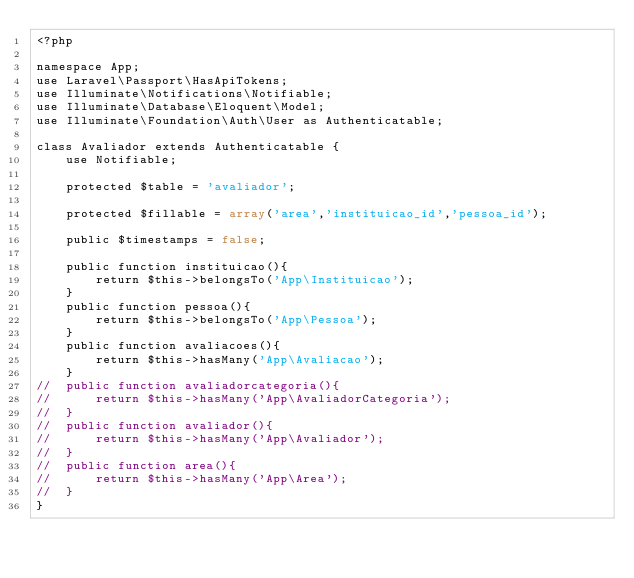<code> <loc_0><loc_0><loc_500><loc_500><_PHP_><?php 

namespace App;
use Laravel\Passport\HasApiTokens;
use Illuminate\Notifications\Notifiable;
use Illuminate\Database\Eloquent\Model;
use Illuminate\Foundation\Auth\User as Authenticatable;

class Avaliador extends Authenticatable {
	use Notifiable;

	protected $table = 'avaliador';

	protected $fillable = array('area','instituicao_id','pessoa_id');

	public $timestamps = false;

	public function instituicao(){
		return $this->belongsTo('App\Instituicao');
	}
	public function pessoa(){
		return $this->belongsTo('App\Pessoa');
	}
	public function avaliacoes(){
		return $this->hasMany('App\Avaliacao');
	}
//	public function avaliadorcategoria(){
//		return $this->hasMany('App\AvaliadorCategoria');
//	}
//	public function avaliador(){
//		return $this->hasMany('App\Avaliador');
//	}
//	public function area(){
//		return $this->hasMany('App\Area');
//	}
}
</code> 